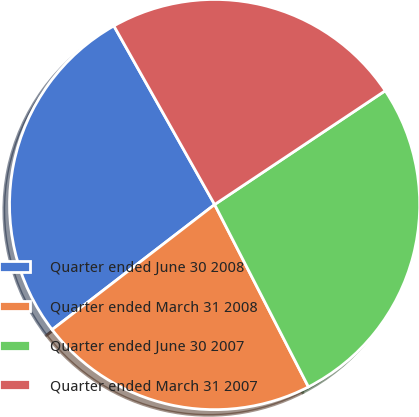Convert chart. <chart><loc_0><loc_0><loc_500><loc_500><pie_chart><fcel>Quarter ended June 30 2008<fcel>Quarter ended March 31 2008<fcel>Quarter ended June 30 2007<fcel>Quarter ended March 31 2007<nl><fcel>27.27%<fcel>22.12%<fcel>26.8%<fcel>23.81%<nl></chart> 